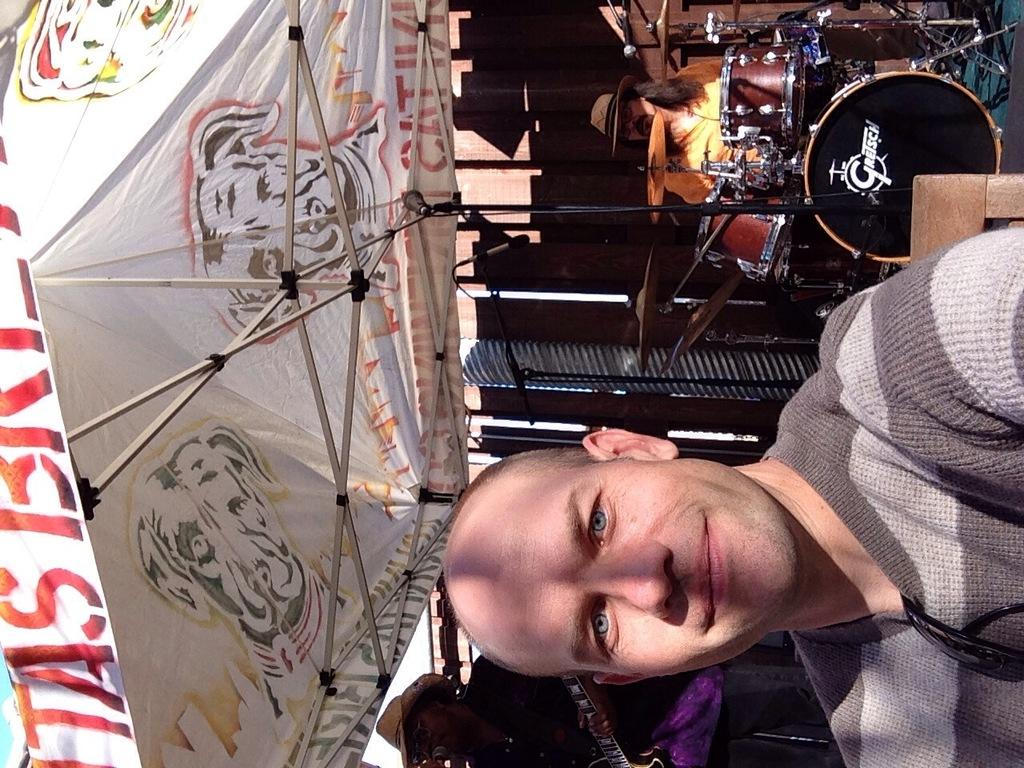Who is the main subject in the image? There is a man in the image. What is the man doing in the image? The man is posing to the camera. Are there any other people in the image besides the man? Yes, there are musicians in the image. What are the musicians doing in the image? The musicians are playing instruments. What type of bead is the woman wearing in the image? There is no woman present in the image, and therefore no bead to describe. 